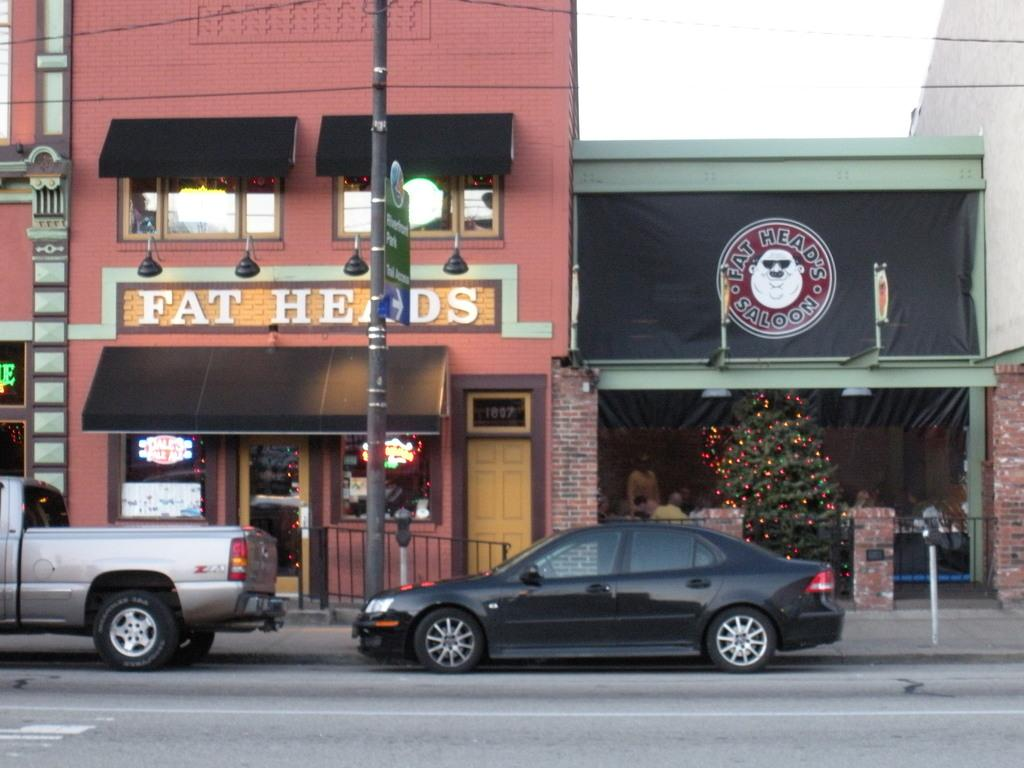<image>
Offer a succinct explanation of the picture presented. silver pickup and black car parked in front of fat heads saloon 